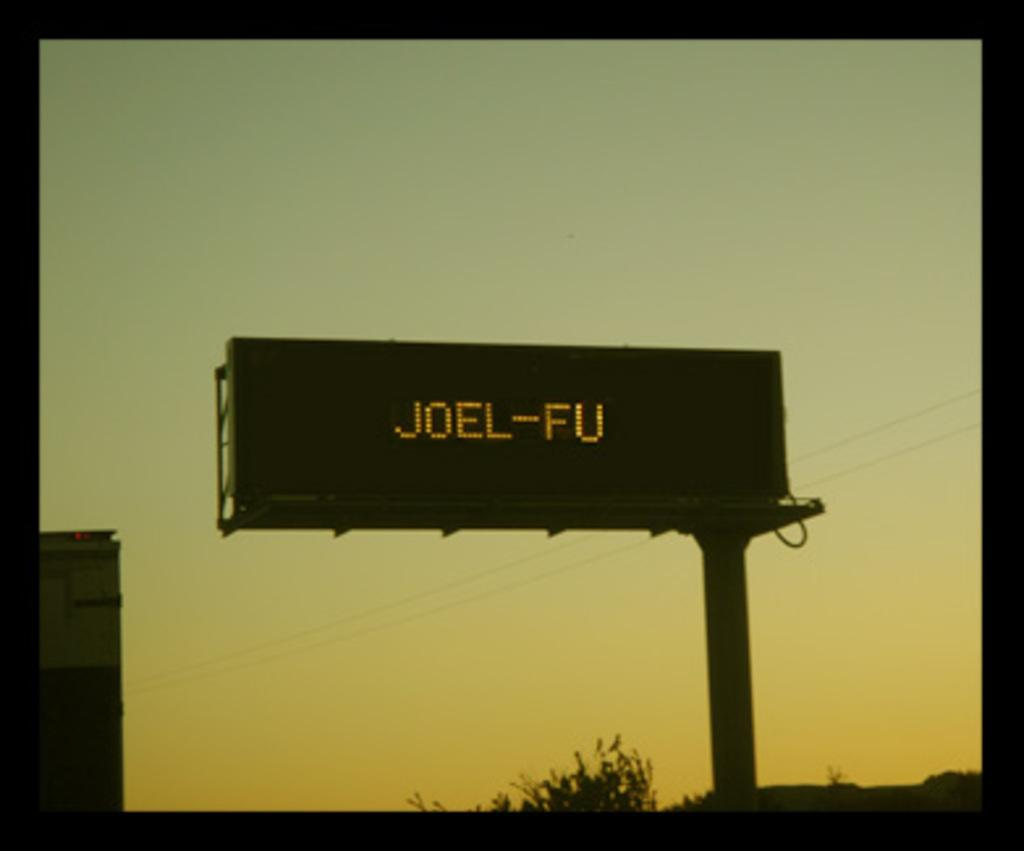<image>
Present a compact description of the photo's key features. A large sign says Joel-FU in LED letters. 